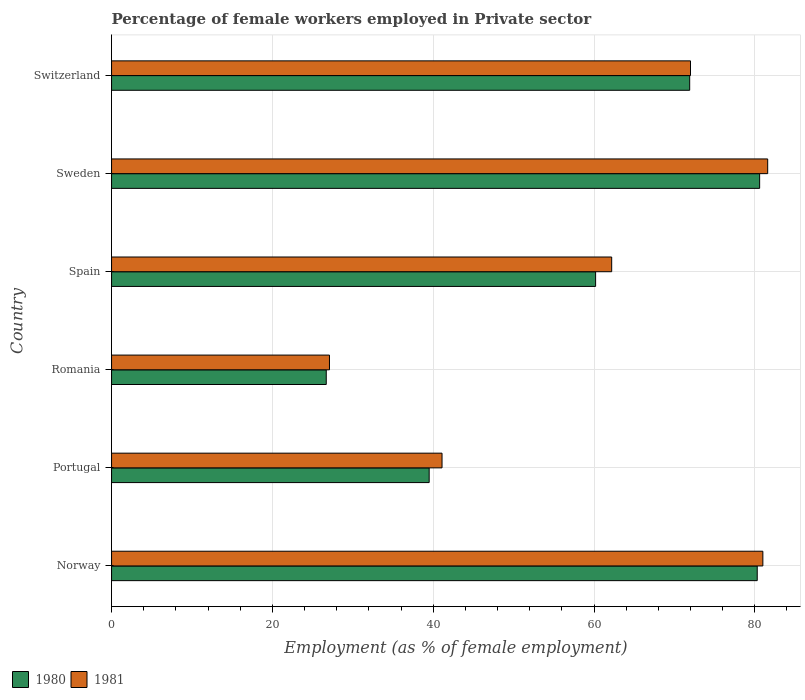Are the number of bars per tick equal to the number of legend labels?
Give a very brief answer. Yes. How many bars are there on the 1st tick from the top?
Provide a short and direct response. 2. How many bars are there on the 2nd tick from the bottom?
Your answer should be compact. 2. What is the percentage of females employed in Private sector in 1980 in Spain?
Your response must be concise. 60.2. Across all countries, what is the maximum percentage of females employed in Private sector in 1981?
Offer a terse response. 81.6. Across all countries, what is the minimum percentage of females employed in Private sector in 1981?
Keep it short and to the point. 27.1. In which country was the percentage of females employed in Private sector in 1981 minimum?
Your answer should be compact. Romania. What is the total percentage of females employed in Private sector in 1981 in the graph?
Your answer should be compact. 365. What is the difference between the percentage of females employed in Private sector in 1980 in Portugal and that in Sweden?
Make the answer very short. -41.1. What is the difference between the percentage of females employed in Private sector in 1981 in Portugal and the percentage of females employed in Private sector in 1980 in Romania?
Make the answer very short. 14.4. What is the average percentage of females employed in Private sector in 1980 per country?
Offer a very short reply. 59.87. What is the difference between the percentage of females employed in Private sector in 1980 and percentage of females employed in Private sector in 1981 in Romania?
Your answer should be very brief. -0.4. What is the ratio of the percentage of females employed in Private sector in 1981 in Portugal to that in Romania?
Offer a terse response. 1.52. What is the difference between the highest and the second highest percentage of females employed in Private sector in 1981?
Your answer should be very brief. 0.6. What is the difference between the highest and the lowest percentage of females employed in Private sector in 1981?
Your response must be concise. 54.5. What does the 2nd bar from the bottom in Norway represents?
Ensure brevity in your answer.  1981. How many bars are there?
Your answer should be very brief. 12. Are all the bars in the graph horizontal?
Offer a very short reply. Yes. How many countries are there in the graph?
Make the answer very short. 6. Are the values on the major ticks of X-axis written in scientific E-notation?
Provide a succinct answer. No. Does the graph contain grids?
Ensure brevity in your answer.  Yes. Where does the legend appear in the graph?
Your answer should be compact. Bottom left. How many legend labels are there?
Ensure brevity in your answer.  2. How are the legend labels stacked?
Provide a short and direct response. Horizontal. What is the title of the graph?
Provide a succinct answer. Percentage of female workers employed in Private sector. Does "1961" appear as one of the legend labels in the graph?
Provide a succinct answer. No. What is the label or title of the X-axis?
Make the answer very short. Employment (as % of female employment). What is the label or title of the Y-axis?
Keep it short and to the point. Country. What is the Employment (as % of female employment) in 1980 in Norway?
Your answer should be very brief. 80.3. What is the Employment (as % of female employment) in 1980 in Portugal?
Provide a succinct answer. 39.5. What is the Employment (as % of female employment) in 1981 in Portugal?
Your response must be concise. 41.1. What is the Employment (as % of female employment) of 1980 in Romania?
Your response must be concise. 26.7. What is the Employment (as % of female employment) of 1981 in Romania?
Give a very brief answer. 27.1. What is the Employment (as % of female employment) in 1980 in Spain?
Offer a very short reply. 60.2. What is the Employment (as % of female employment) of 1981 in Spain?
Offer a terse response. 62.2. What is the Employment (as % of female employment) in 1980 in Sweden?
Your answer should be very brief. 80.6. What is the Employment (as % of female employment) of 1981 in Sweden?
Provide a succinct answer. 81.6. What is the Employment (as % of female employment) of 1980 in Switzerland?
Your answer should be very brief. 71.9. Across all countries, what is the maximum Employment (as % of female employment) in 1980?
Ensure brevity in your answer.  80.6. Across all countries, what is the maximum Employment (as % of female employment) of 1981?
Keep it short and to the point. 81.6. Across all countries, what is the minimum Employment (as % of female employment) in 1980?
Make the answer very short. 26.7. Across all countries, what is the minimum Employment (as % of female employment) of 1981?
Keep it short and to the point. 27.1. What is the total Employment (as % of female employment) of 1980 in the graph?
Keep it short and to the point. 359.2. What is the total Employment (as % of female employment) of 1981 in the graph?
Provide a succinct answer. 365. What is the difference between the Employment (as % of female employment) in 1980 in Norway and that in Portugal?
Your answer should be compact. 40.8. What is the difference between the Employment (as % of female employment) of 1981 in Norway and that in Portugal?
Provide a succinct answer. 39.9. What is the difference between the Employment (as % of female employment) of 1980 in Norway and that in Romania?
Provide a succinct answer. 53.6. What is the difference between the Employment (as % of female employment) in 1981 in Norway and that in Romania?
Provide a short and direct response. 53.9. What is the difference between the Employment (as % of female employment) in 1980 in Norway and that in Spain?
Ensure brevity in your answer.  20.1. What is the difference between the Employment (as % of female employment) in 1981 in Norway and that in Spain?
Your answer should be very brief. 18.8. What is the difference between the Employment (as % of female employment) of 1981 in Norway and that in Sweden?
Provide a succinct answer. -0.6. What is the difference between the Employment (as % of female employment) in 1981 in Norway and that in Switzerland?
Your answer should be very brief. 9. What is the difference between the Employment (as % of female employment) in 1981 in Portugal and that in Romania?
Provide a succinct answer. 14. What is the difference between the Employment (as % of female employment) of 1980 in Portugal and that in Spain?
Ensure brevity in your answer.  -20.7. What is the difference between the Employment (as % of female employment) of 1981 in Portugal and that in Spain?
Your response must be concise. -21.1. What is the difference between the Employment (as % of female employment) in 1980 in Portugal and that in Sweden?
Your answer should be compact. -41.1. What is the difference between the Employment (as % of female employment) of 1981 in Portugal and that in Sweden?
Provide a succinct answer. -40.5. What is the difference between the Employment (as % of female employment) of 1980 in Portugal and that in Switzerland?
Keep it short and to the point. -32.4. What is the difference between the Employment (as % of female employment) of 1981 in Portugal and that in Switzerland?
Provide a succinct answer. -30.9. What is the difference between the Employment (as % of female employment) in 1980 in Romania and that in Spain?
Provide a short and direct response. -33.5. What is the difference between the Employment (as % of female employment) of 1981 in Romania and that in Spain?
Keep it short and to the point. -35.1. What is the difference between the Employment (as % of female employment) of 1980 in Romania and that in Sweden?
Provide a succinct answer. -53.9. What is the difference between the Employment (as % of female employment) of 1981 in Romania and that in Sweden?
Provide a short and direct response. -54.5. What is the difference between the Employment (as % of female employment) of 1980 in Romania and that in Switzerland?
Offer a very short reply. -45.2. What is the difference between the Employment (as % of female employment) of 1981 in Romania and that in Switzerland?
Keep it short and to the point. -44.9. What is the difference between the Employment (as % of female employment) of 1980 in Spain and that in Sweden?
Offer a terse response. -20.4. What is the difference between the Employment (as % of female employment) in 1981 in Spain and that in Sweden?
Your answer should be very brief. -19.4. What is the difference between the Employment (as % of female employment) of 1980 in Norway and the Employment (as % of female employment) of 1981 in Portugal?
Your answer should be very brief. 39.2. What is the difference between the Employment (as % of female employment) of 1980 in Norway and the Employment (as % of female employment) of 1981 in Romania?
Your response must be concise. 53.2. What is the difference between the Employment (as % of female employment) of 1980 in Norway and the Employment (as % of female employment) of 1981 in Spain?
Provide a short and direct response. 18.1. What is the difference between the Employment (as % of female employment) of 1980 in Portugal and the Employment (as % of female employment) of 1981 in Spain?
Give a very brief answer. -22.7. What is the difference between the Employment (as % of female employment) of 1980 in Portugal and the Employment (as % of female employment) of 1981 in Sweden?
Your response must be concise. -42.1. What is the difference between the Employment (as % of female employment) in 1980 in Portugal and the Employment (as % of female employment) in 1981 in Switzerland?
Make the answer very short. -32.5. What is the difference between the Employment (as % of female employment) of 1980 in Romania and the Employment (as % of female employment) of 1981 in Spain?
Make the answer very short. -35.5. What is the difference between the Employment (as % of female employment) in 1980 in Romania and the Employment (as % of female employment) in 1981 in Sweden?
Offer a very short reply. -54.9. What is the difference between the Employment (as % of female employment) in 1980 in Romania and the Employment (as % of female employment) in 1981 in Switzerland?
Offer a terse response. -45.3. What is the difference between the Employment (as % of female employment) in 1980 in Spain and the Employment (as % of female employment) in 1981 in Sweden?
Ensure brevity in your answer.  -21.4. What is the difference between the Employment (as % of female employment) in 1980 in Spain and the Employment (as % of female employment) in 1981 in Switzerland?
Make the answer very short. -11.8. What is the difference between the Employment (as % of female employment) in 1980 in Sweden and the Employment (as % of female employment) in 1981 in Switzerland?
Your answer should be compact. 8.6. What is the average Employment (as % of female employment) of 1980 per country?
Offer a very short reply. 59.87. What is the average Employment (as % of female employment) of 1981 per country?
Provide a succinct answer. 60.83. What is the difference between the Employment (as % of female employment) in 1980 and Employment (as % of female employment) in 1981 in Norway?
Ensure brevity in your answer.  -0.7. What is the difference between the Employment (as % of female employment) in 1980 and Employment (as % of female employment) in 1981 in Spain?
Your response must be concise. -2. What is the difference between the Employment (as % of female employment) in 1980 and Employment (as % of female employment) in 1981 in Switzerland?
Make the answer very short. -0.1. What is the ratio of the Employment (as % of female employment) of 1980 in Norway to that in Portugal?
Make the answer very short. 2.03. What is the ratio of the Employment (as % of female employment) in 1981 in Norway to that in Portugal?
Your answer should be very brief. 1.97. What is the ratio of the Employment (as % of female employment) of 1980 in Norway to that in Romania?
Ensure brevity in your answer.  3.01. What is the ratio of the Employment (as % of female employment) in 1981 in Norway to that in Romania?
Keep it short and to the point. 2.99. What is the ratio of the Employment (as % of female employment) of 1980 in Norway to that in Spain?
Make the answer very short. 1.33. What is the ratio of the Employment (as % of female employment) in 1981 in Norway to that in Spain?
Offer a very short reply. 1.3. What is the ratio of the Employment (as % of female employment) in 1980 in Norway to that in Switzerland?
Ensure brevity in your answer.  1.12. What is the ratio of the Employment (as % of female employment) of 1980 in Portugal to that in Romania?
Offer a very short reply. 1.48. What is the ratio of the Employment (as % of female employment) in 1981 in Portugal to that in Romania?
Provide a short and direct response. 1.52. What is the ratio of the Employment (as % of female employment) in 1980 in Portugal to that in Spain?
Keep it short and to the point. 0.66. What is the ratio of the Employment (as % of female employment) in 1981 in Portugal to that in Spain?
Offer a very short reply. 0.66. What is the ratio of the Employment (as % of female employment) of 1980 in Portugal to that in Sweden?
Offer a very short reply. 0.49. What is the ratio of the Employment (as % of female employment) in 1981 in Portugal to that in Sweden?
Ensure brevity in your answer.  0.5. What is the ratio of the Employment (as % of female employment) of 1980 in Portugal to that in Switzerland?
Ensure brevity in your answer.  0.55. What is the ratio of the Employment (as % of female employment) of 1981 in Portugal to that in Switzerland?
Offer a terse response. 0.57. What is the ratio of the Employment (as % of female employment) in 1980 in Romania to that in Spain?
Your response must be concise. 0.44. What is the ratio of the Employment (as % of female employment) of 1981 in Romania to that in Spain?
Make the answer very short. 0.44. What is the ratio of the Employment (as % of female employment) of 1980 in Romania to that in Sweden?
Offer a very short reply. 0.33. What is the ratio of the Employment (as % of female employment) in 1981 in Romania to that in Sweden?
Provide a succinct answer. 0.33. What is the ratio of the Employment (as % of female employment) in 1980 in Romania to that in Switzerland?
Your answer should be compact. 0.37. What is the ratio of the Employment (as % of female employment) of 1981 in Romania to that in Switzerland?
Your answer should be very brief. 0.38. What is the ratio of the Employment (as % of female employment) in 1980 in Spain to that in Sweden?
Your response must be concise. 0.75. What is the ratio of the Employment (as % of female employment) of 1981 in Spain to that in Sweden?
Keep it short and to the point. 0.76. What is the ratio of the Employment (as % of female employment) in 1980 in Spain to that in Switzerland?
Your answer should be very brief. 0.84. What is the ratio of the Employment (as % of female employment) in 1981 in Spain to that in Switzerland?
Keep it short and to the point. 0.86. What is the ratio of the Employment (as % of female employment) of 1980 in Sweden to that in Switzerland?
Keep it short and to the point. 1.12. What is the ratio of the Employment (as % of female employment) in 1981 in Sweden to that in Switzerland?
Your answer should be compact. 1.13. What is the difference between the highest and the second highest Employment (as % of female employment) of 1980?
Ensure brevity in your answer.  0.3. What is the difference between the highest and the second highest Employment (as % of female employment) in 1981?
Your answer should be compact. 0.6. What is the difference between the highest and the lowest Employment (as % of female employment) of 1980?
Offer a terse response. 53.9. What is the difference between the highest and the lowest Employment (as % of female employment) of 1981?
Your answer should be compact. 54.5. 